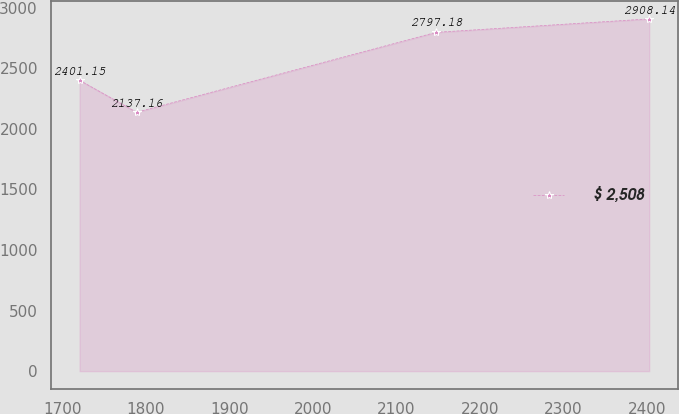Convert chart. <chart><loc_0><loc_0><loc_500><loc_500><line_chart><ecel><fcel>$ 2,508<nl><fcel>1720.56<fcel>2401.15<nl><fcel>1788.77<fcel>2137.16<nl><fcel>2147.69<fcel>2797.18<nl><fcel>2402.71<fcel>2908.14<nl></chart> 